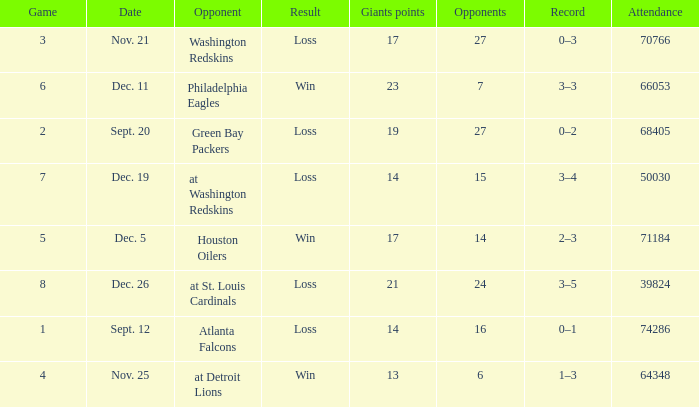What is the record when the opponent is washington redskins? 0–3. 